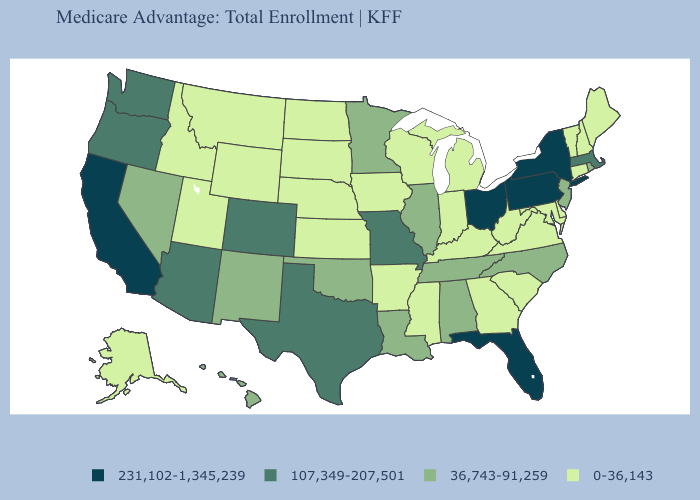Does New Jersey have the highest value in the Northeast?
Write a very short answer. No. Does Washington have the lowest value in the USA?
Short answer required. No. What is the value of Missouri?
Write a very short answer. 107,349-207,501. What is the value of New Hampshire?
Give a very brief answer. 0-36,143. Which states have the lowest value in the Northeast?
Keep it brief. Connecticut, Maine, New Hampshire, Vermont. Among the states that border Connecticut , does Massachusetts have the highest value?
Keep it brief. No. What is the highest value in the Northeast ?
Short answer required. 231,102-1,345,239. What is the highest value in states that border Georgia?
Concise answer only. 231,102-1,345,239. What is the lowest value in the MidWest?
Answer briefly. 0-36,143. What is the highest value in the USA?
Answer briefly. 231,102-1,345,239. What is the highest value in the Northeast ?
Quick response, please. 231,102-1,345,239. What is the lowest value in the USA?
Answer briefly. 0-36,143. Name the states that have a value in the range 0-36,143?
Concise answer only. Alaska, Arkansas, Connecticut, Delaware, Georgia, Iowa, Idaho, Indiana, Kansas, Kentucky, Maryland, Maine, Michigan, Mississippi, Montana, North Dakota, Nebraska, New Hampshire, South Carolina, South Dakota, Utah, Virginia, Vermont, Wisconsin, West Virginia, Wyoming. How many symbols are there in the legend?
Keep it brief. 4. Which states have the lowest value in the South?
Give a very brief answer. Arkansas, Delaware, Georgia, Kentucky, Maryland, Mississippi, South Carolina, Virginia, West Virginia. 